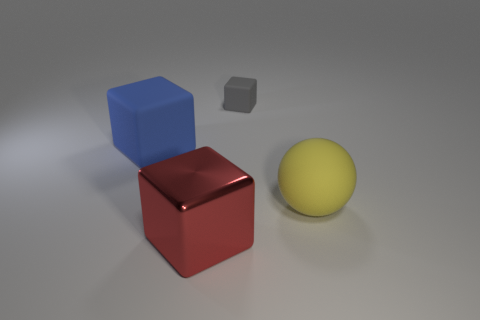Can you describe the setting of these objects? The objects are placed on a flat, neutral-toned surface that gives the impression of an open space with a controlled lighting setup. This kind of setting is commonly used in 3D modeling and product visualization to focus attention on the objects themselves, without any visual distraction from the background. 